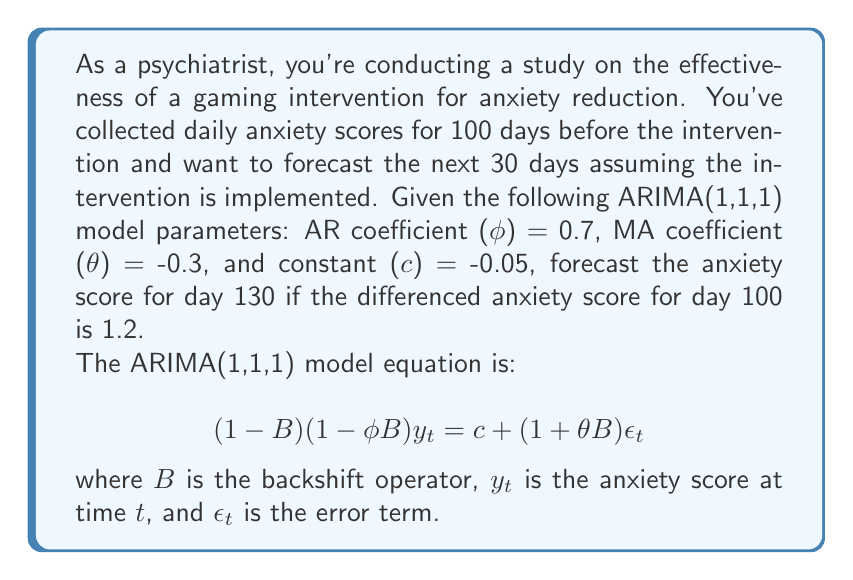Can you answer this question? Let's approach this step-by-step:

1) First, we need to understand what the differenced series represents. Since we're using first-order differencing (d=1), we have:
   
   $$w_t = (1-B)y_t = y_t - y_{t-1}$$

2) The ARIMA(1,1,1) model for the differenced series can be written as:

   $$(1-\phi B)w_t = c + (1+\theta B)\epsilon_t$$

3) Expanding this equation:

   $$w_t - \phi w_{t-1} = c + \epsilon_t + \theta \epsilon_{t-1}$$

4) For forecasting, we set future error terms to their expected value of 0:

   $$E(w_t) - \phi E(w_{t-1}) = c$$

5) Let's denote the forecast for day t as $\hat{w}_t$. We're given that $w_{100} = 1.2$. We need to forecast for 30 days ahead, so we'll iterate this process 30 times.

6) For day 101:
   
   $$\hat{w}_{101} = \phi w_{100} + c = 0.7(1.2) + (-0.05) = 0.79$$

7) For day 102:
   
   $$\hat{w}_{102} = \phi \hat{w}_{101} + c = 0.7(0.79) + (-0.05) = 0.503$$

8) We continue this process until day 130. After 30 iterations, we get:
   
   $$\hat{w}_{130} \approx -0.0478$$

9) However, this is the forecast for the differenced series. To get the actual anxiety score forecast, we need to "undifference" the series:

   $$\hat{y}_{130} = y_{100} + \sum_{t=101}^{130} \hat{w}_t$$

10) The sum of the differenced forecasts from day 101 to 130 is approximately 4.9206.

11) Therefore, the forecast for the anxiety score on day 130 is:

    $$\hat{y}_{130} = y_{100} + 4.9206$$

    Note that we don't know the actual value of $y_{100}$, so we can't provide a specific numeric forecast.
Answer: $\hat{y}_{130} = y_{100} + 4.9206$ 